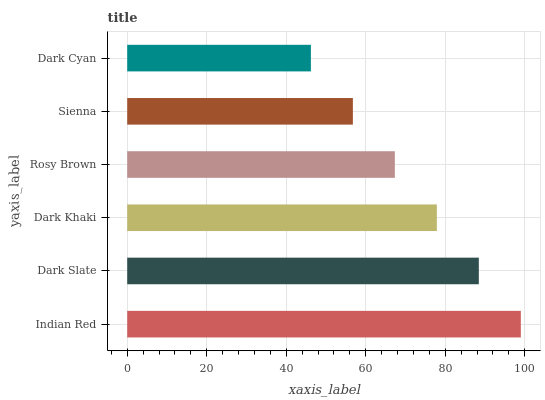Is Dark Cyan the minimum?
Answer yes or no. Yes. Is Indian Red the maximum?
Answer yes or no. Yes. Is Dark Slate the minimum?
Answer yes or no. No. Is Dark Slate the maximum?
Answer yes or no. No. Is Indian Red greater than Dark Slate?
Answer yes or no. Yes. Is Dark Slate less than Indian Red?
Answer yes or no. Yes. Is Dark Slate greater than Indian Red?
Answer yes or no. No. Is Indian Red less than Dark Slate?
Answer yes or no. No. Is Dark Khaki the high median?
Answer yes or no. Yes. Is Rosy Brown the low median?
Answer yes or no. Yes. Is Indian Red the high median?
Answer yes or no. No. Is Indian Red the low median?
Answer yes or no. No. 